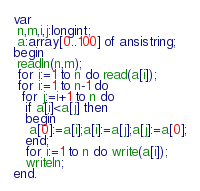Convert code to text. <code><loc_0><loc_0><loc_500><loc_500><_Pascal_>var
 n,m,i,j:longint;
 a:array[0..100] of ansistring;
begin
 readln(n,m);
 for i:=1 to n do read(a[i]);
 for i:=1 to n-1 do
  for j:=i+1 to n do
   if a[i]<a[j] then
   begin
    a[0]:=a[i];a[i]:=a[j];a[j]:=a[0];
   end;
   for i:=1 to n do write(a[i]);
   writeln;
end.</code> 